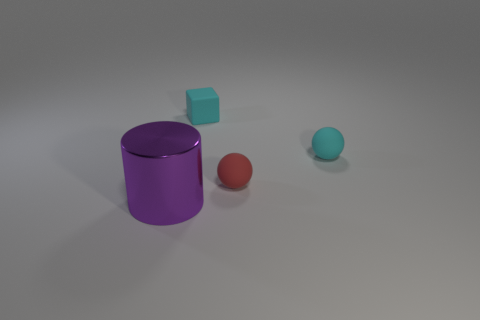Add 1 large yellow rubber cubes. How many objects exist? 5 Subtract all cylinders. How many objects are left? 3 Add 3 rubber balls. How many rubber balls are left? 5 Add 1 green shiny blocks. How many green shiny blocks exist? 1 Subtract 0 gray cubes. How many objects are left? 4 Subtract all green spheres. Subtract all red spheres. How many objects are left? 3 